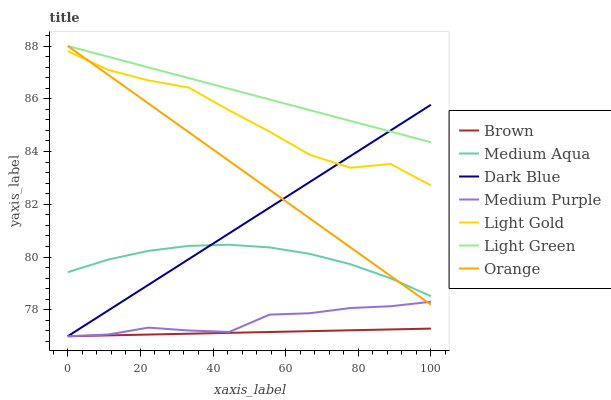Does Brown have the minimum area under the curve?
Answer yes or no. Yes. Does Light Green have the maximum area under the curve?
Answer yes or no. Yes. Does Medium Purple have the minimum area under the curve?
Answer yes or no. No. Does Medium Purple have the maximum area under the curve?
Answer yes or no. No. Is Brown the smoothest?
Answer yes or no. Yes. Is Light Gold the roughest?
Answer yes or no. Yes. Is Medium Purple the smoothest?
Answer yes or no. No. Is Medium Purple the roughest?
Answer yes or no. No. Does Medium Aqua have the lowest value?
Answer yes or no. No. Does Orange have the highest value?
Answer yes or no. Yes. Does Medium Purple have the highest value?
Answer yes or no. No. Is Light Gold less than Light Green?
Answer yes or no. Yes. Is Light Gold greater than Medium Aqua?
Answer yes or no. Yes. Does Light Gold intersect Light Green?
Answer yes or no. No. 